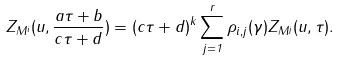Convert formula to latex. <formula><loc_0><loc_0><loc_500><loc_500>Z _ { M ^ { i } } ( u , \frac { a \tau + b } { c \tau + d } ) = ( c \tau + d ) ^ { k } \sum _ { j = 1 } ^ { r } \rho _ { i , j } ( \gamma ) Z _ { M ^ { j } } ( u , \tau ) .</formula> 